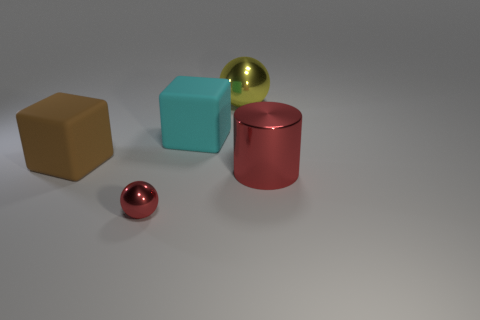Subtract all gray cylinders. Subtract all brown spheres. How many cylinders are left? 1 Add 4 rubber spheres. How many objects exist? 9 Subtract all cubes. How many objects are left? 3 Add 3 metallic spheres. How many metallic spheres exist? 5 Subtract 0 blue cylinders. How many objects are left? 5 Subtract all yellow spheres. Subtract all cyan things. How many objects are left? 3 Add 2 big brown matte things. How many big brown matte things are left? 3 